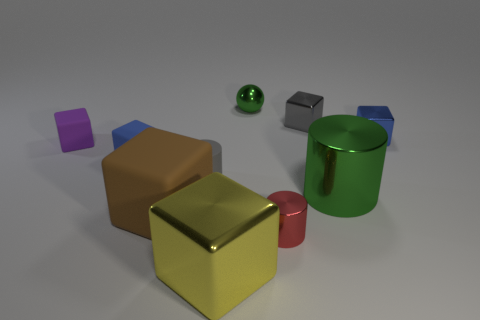Subtract all purple blocks. How many blocks are left? 5 Subtract all purple cubes. How many cubes are left? 5 Subtract all red blocks. Subtract all gray spheres. How many blocks are left? 6 Subtract all spheres. How many objects are left? 9 Add 5 purple metallic things. How many purple metallic things exist? 5 Subtract 0 red cubes. How many objects are left? 10 Subtract all small red metal spheres. Subtract all tiny gray cubes. How many objects are left? 9 Add 8 red metal cylinders. How many red metal cylinders are left? 9 